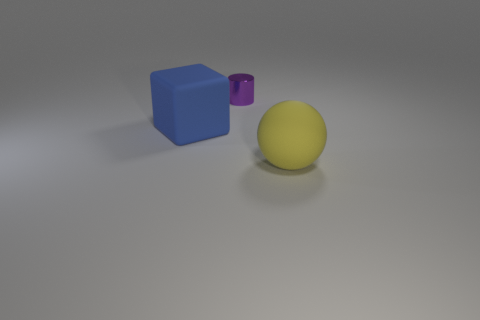How many things are rubber cubes or objects that are behind the big yellow thing? Including the big yellow sphere in the front, there are two objects visible in the image: one large blue cube and one smaller purple cylinder. There are no objects behind the big yellow sphere that can be seen from this angle. If the question is specifically about rubber cubes, from the image alone, we cannot determine the materials of the objects. 